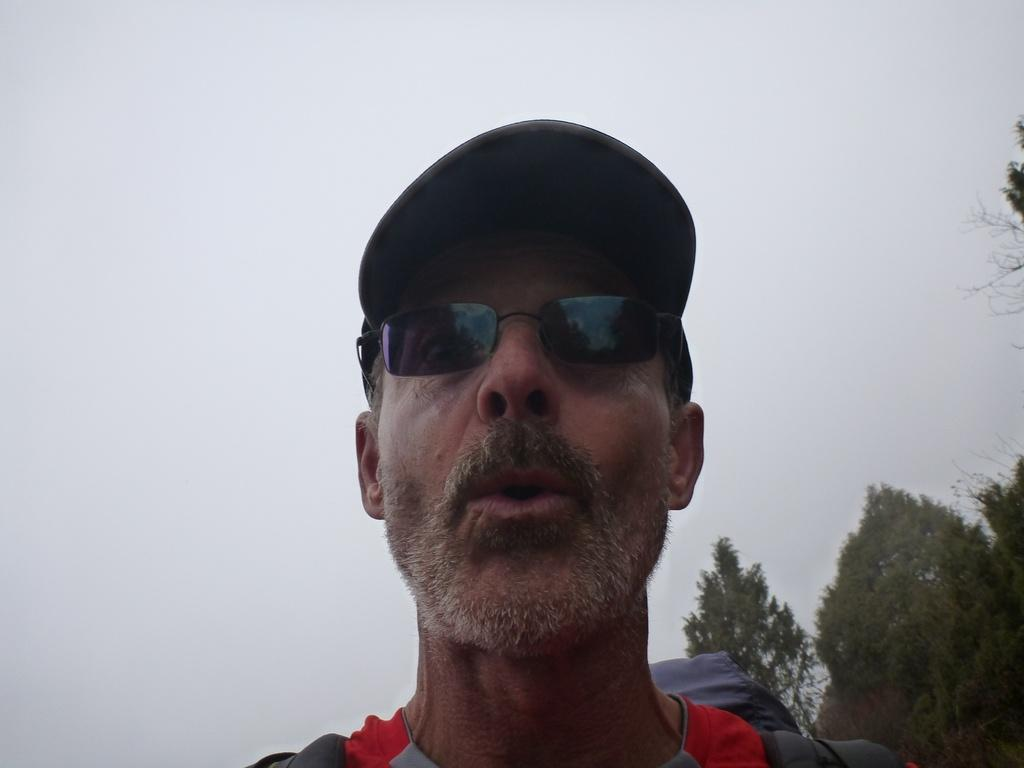Who is the main subject in the image? There is a man in the center of the image. What can be seen in the background of the image? There are trees in the background of the image. What type of punishment is the man receiving in the image? There is no indication of punishment in the image; it simply shows a man in the center and trees in the background. 